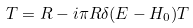Convert formula to latex. <formula><loc_0><loc_0><loc_500><loc_500>T = R - i \pi R \delta ( E - H _ { 0 } ) T</formula> 